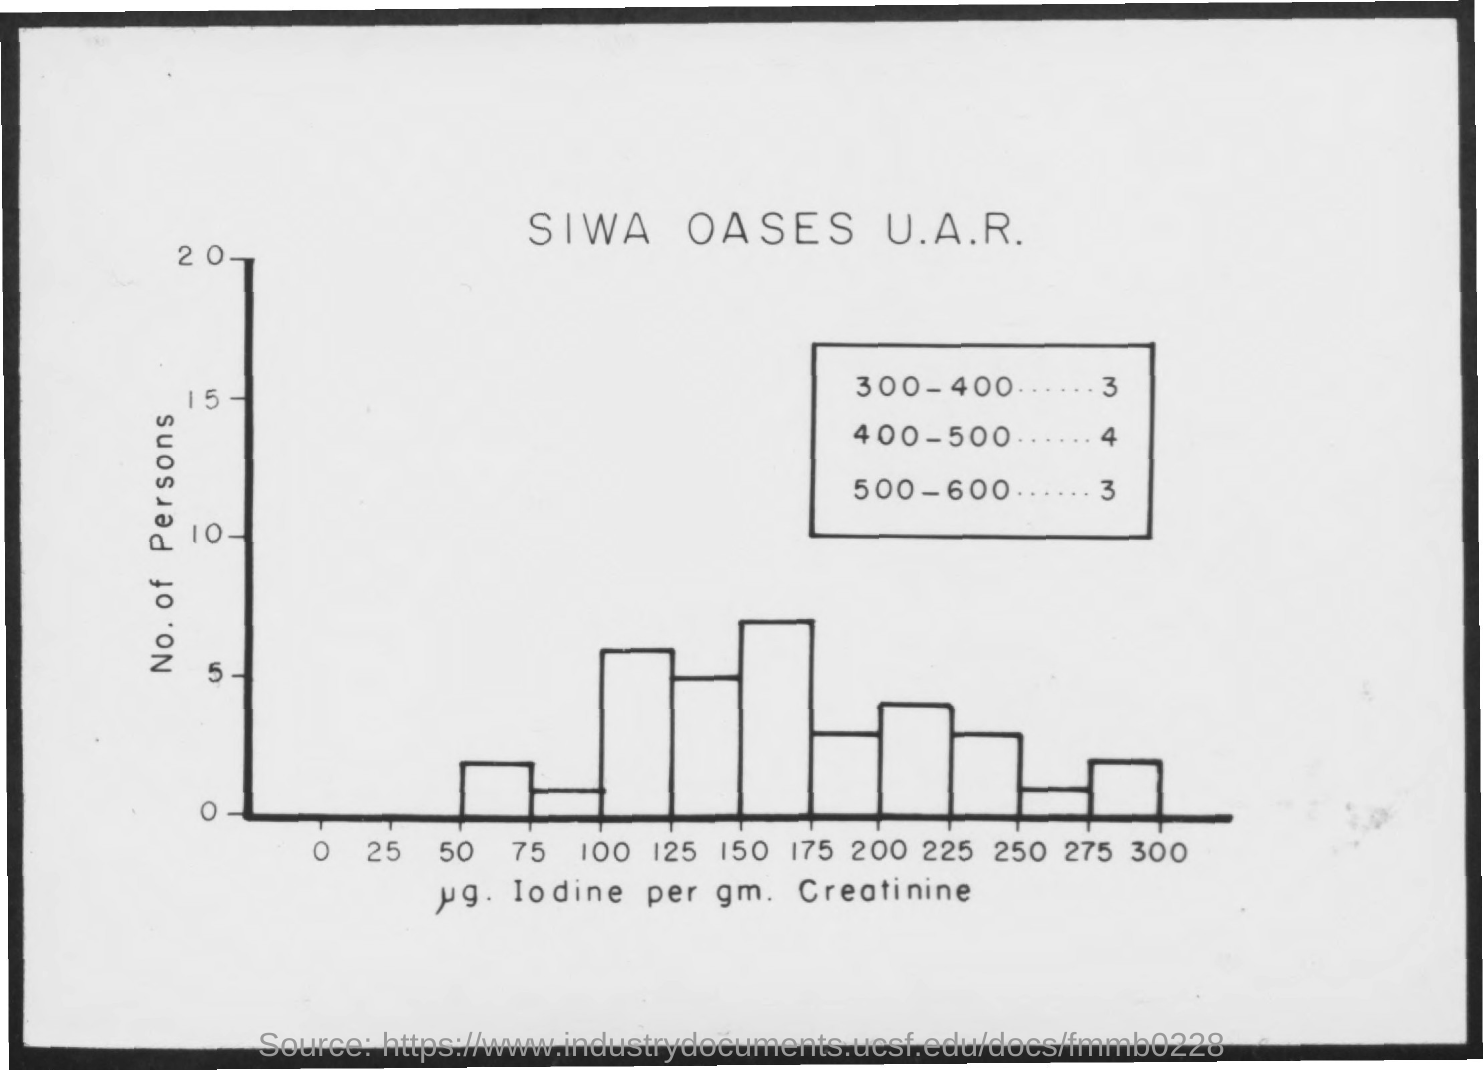Identify some key points in this picture. The y-axis represents the number of people in the graph. 